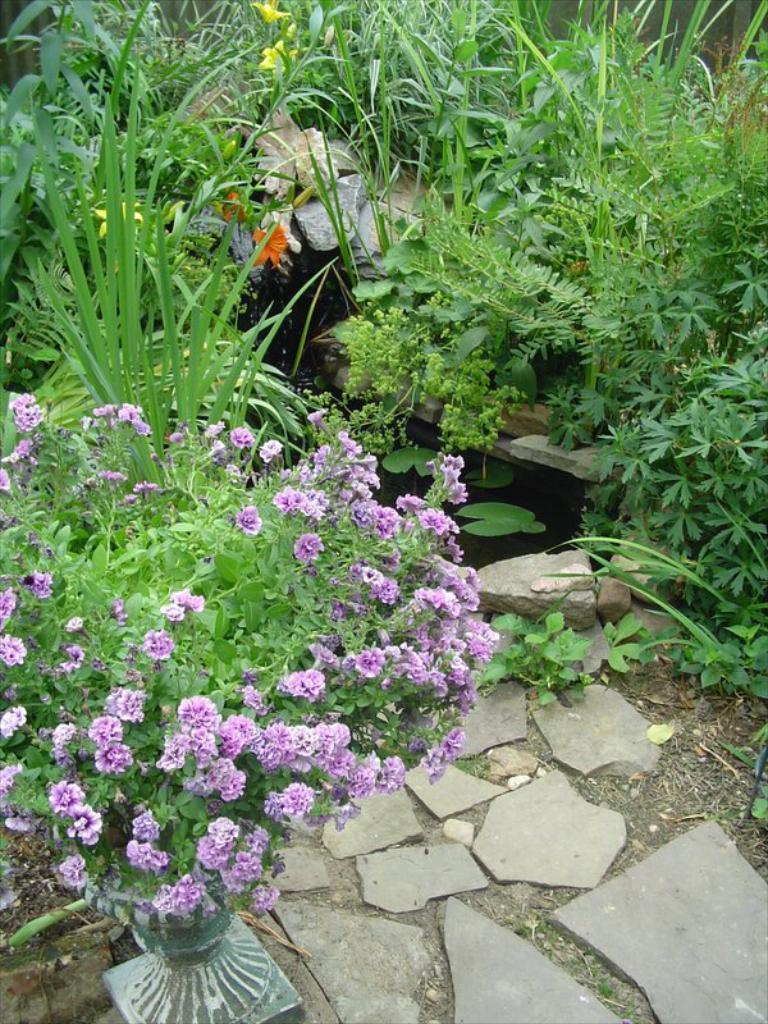How would you summarize this image in a sentence or two? In this image I can see many plants on the ground. On the left side, I can see some flowers on a plant. 